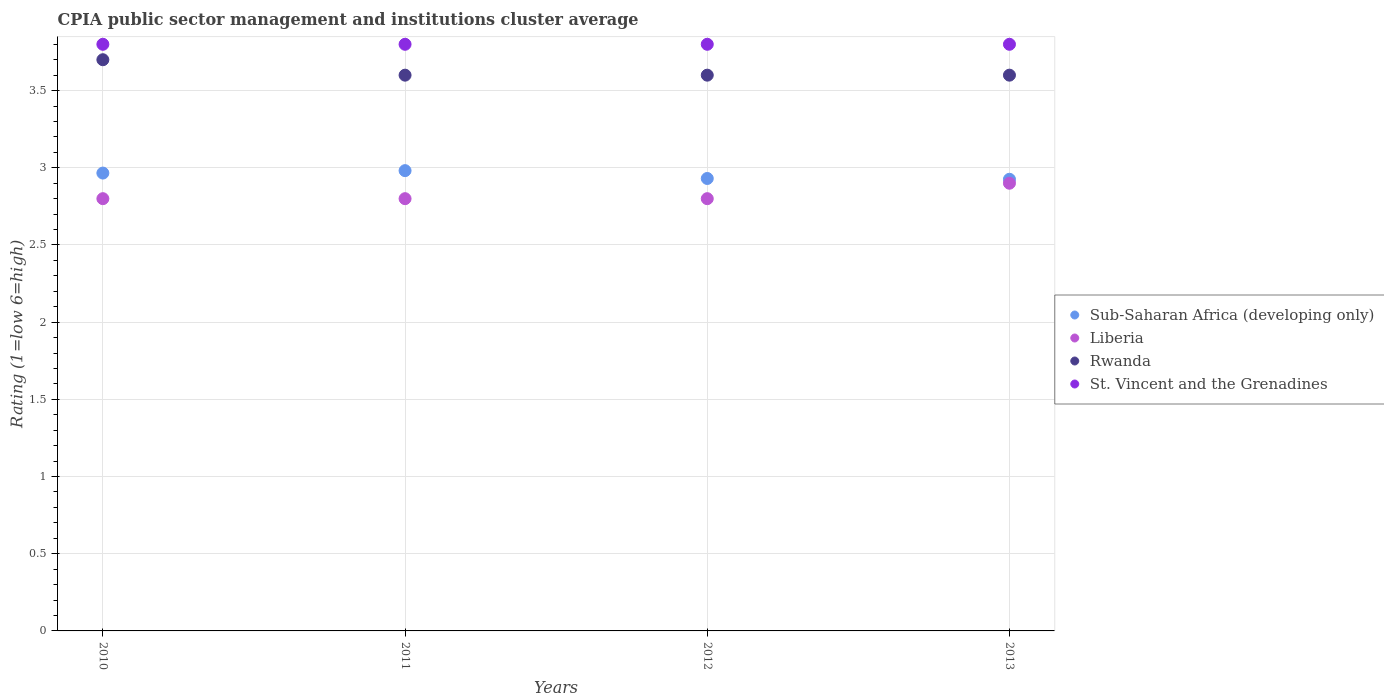What is the CPIA rating in St. Vincent and the Grenadines in 2013?
Keep it short and to the point. 3.8. What is the total CPIA rating in St. Vincent and the Grenadines in the graph?
Your answer should be compact. 15.2. What is the difference between the CPIA rating in Sub-Saharan Africa (developing only) in 2012 and that in 2013?
Offer a very short reply. 0.01. What is the difference between the CPIA rating in Liberia in 2013 and the CPIA rating in Rwanda in 2010?
Offer a terse response. -0.8. What is the average CPIA rating in St. Vincent and the Grenadines per year?
Make the answer very short. 3.8. In the year 2012, what is the difference between the CPIA rating in Sub-Saharan Africa (developing only) and CPIA rating in Liberia?
Your answer should be very brief. 0.13. In how many years, is the CPIA rating in Sub-Saharan Africa (developing only) greater than 1?
Your answer should be very brief. 4. What is the ratio of the CPIA rating in Sub-Saharan Africa (developing only) in 2010 to that in 2013?
Keep it short and to the point. 1.01. What is the difference between the highest and the second highest CPIA rating in Rwanda?
Offer a terse response. 0.1. What is the difference between the highest and the lowest CPIA rating in Rwanda?
Make the answer very short. 0.1. In how many years, is the CPIA rating in Rwanda greater than the average CPIA rating in Rwanda taken over all years?
Provide a short and direct response. 1. Is the sum of the CPIA rating in St. Vincent and the Grenadines in 2011 and 2012 greater than the maximum CPIA rating in Sub-Saharan Africa (developing only) across all years?
Your answer should be compact. Yes. How many dotlines are there?
Keep it short and to the point. 4. Are the values on the major ticks of Y-axis written in scientific E-notation?
Give a very brief answer. No. Does the graph contain any zero values?
Keep it short and to the point. No. What is the title of the graph?
Ensure brevity in your answer.  CPIA public sector management and institutions cluster average. What is the label or title of the X-axis?
Offer a terse response. Years. What is the label or title of the Y-axis?
Provide a short and direct response. Rating (1=low 6=high). What is the Rating (1=low 6=high) in Sub-Saharan Africa (developing only) in 2010?
Keep it short and to the point. 2.97. What is the Rating (1=low 6=high) of Sub-Saharan Africa (developing only) in 2011?
Provide a short and direct response. 2.98. What is the Rating (1=low 6=high) in Sub-Saharan Africa (developing only) in 2012?
Make the answer very short. 2.93. What is the Rating (1=low 6=high) in Liberia in 2012?
Offer a very short reply. 2.8. What is the Rating (1=low 6=high) in Rwanda in 2012?
Ensure brevity in your answer.  3.6. What is the Rating (1=low 6=high) of St. Vincent and the Grenadines in 2012?
Your response must be concise. 3.8. What is the Rating (1=low 6=high) in Sub-Saharan Africa (developing only) in 2013?
Offer a very short reply. 2.93. What is the Rating (1=low 6=high) in Liberia in 2013?
Your answer should be very brief. 2.9. Across all years, what is the maximum Rating (1=low 6=high) in Sub-Saharan Africa (developing only)?
Provide a short and direct response. 2.98. Across all years, what is the maximum Rating (1=low 6=high) of Rwanda?
Make the answer very short. 3.7. Across all years, what is the maximum Rating (1=low 6=high) of St. Vincent and the Grenadines?
Make the answer very short. 3.8. Across all years, what is the minimum Rating (1=low 6=high) of Sub-Saharan Africa (developing only)?
Give a very brief answer. 2.93. Across all years, what is the minimum Rating (1=low 6=high) in Rwanda?
Provide a succinct answer. 3.6. What is the total Rating (1=low 6=high) of Sub-Saharan Africa (developing only) in the graph?
Your answer should be very brief. 11.8. What is the total Rating (1=low 6=high) of St. Vincent and the Grenadines in the graph?
Your answer should be very brief. 15.2. What is the difference between the Rating (1=low 6=high) in Sub-Saharan Africa (developing only) in 2010 and that in 2011?
Your answer should be very brief. -0.02. What is the difference between the Rating (1=low 6=high) of Liberia in 2010 and that in 2011?
Your answer should be very brief. 0. What is the difference between the Rating (1=low 6=high) of Rwanda in 2010 and that in 2011?
Give a very brief answer. 0.1. What is the difference between the Rating (1=low 6=high) in St. Vincent and the Grenadines in 2010 and that in 2011?
Give a very brief answer. 0. What is the difference between the Rating (1=low 6=high) in Sub-Saharan Africa (developing only) in 2010 and that in 2012?
Offer a very short reply. 0.04. What is the difference between the Rating (1=low 6=high) in Liberia in 2010 and that in 2012?
Your answer should be compact. 0. What is the difference between the Rating (1=low 6=high) of St. Vincent and the Grenadines in 2010 and that in 2012?
Ensure brevity in your answer.  0. What is the difference between the Rating (1=low 6=high) in Sub-Saharan Africa (developing only) in 2010 and that in 2013?
Keep it short and to the point. 0.04. What is the difference between the Rating (1=low 6=high) in Liberia in 2010 and that in 2013?
Offer a terse response. -0.1. What is the difference between the Rating (1=low 6=high) of Rwanda in 2010 and that in 2013?
Your response must be concise. 0.1. What is the difference between the Rating (1=low 6=high) of Sub-Saharan Africa (developing only) in 2011 and that in 2012?
Provide a succinct answer. 0.05. What is the difference between the Rating (1=low 6=high) in Liberia in 2011 and that in 2012?
Give a very brief answer. 0. What is the difference between the Rating (1=low 6=high) in St. Vincent and the Grenadines in 2011 and that in 2012?
Provide a short and direct response. 0. What is the difference between the Rating (1=low 6=high) in Sub-Saharan Africa (developing only) in 2011 and that in 2013?
Your response must be concise. 0.06. What is the difference between the Rating (1=low 6=high) of Rwanda in 2011 and that in 2013?
Make the answer very short. 0. What is the difference between the Rating (1=low 6=high) in Sub-Saharan Africa (developing only) in 2012 and that in 2013?
Give a very brief answer. 0.01. What is the difference between the Rating (1=low 6=high) of Rwanda in 2012 and that in 2013?
Offer a very short reply. 0. What is the difference between the Rating (1=low 6=high) of St. Vincent and the Grenadines in 2012 and that in 2013?
Give a very brief answer. 0. What is the difference between the Rating (1=low 6=high) of Sub-Saharan Africa (developing only) in 2010 and the Rating (1=low 6=high) of Liberia in 2011?
Provide a short and direct response. 0.17. What is the difference between the Rating (1=low 6=high) of Sub-Saharan Africa (developing only) in 2010 and the Rating (1=low 6=high) of Rwanda in 2011?
Ensure brevity in your answer.  -0.63. What is the difference between the Rating (1=low 6=high) of Sub-Saharan Africa (developing only) in 2010 and the Rating (1=low 6=high) of St. Vincent and the Grenadines in 2011?
Make the answer very short. -0.83. What is the difference between the Rating (1=low 6=high) in Liberia in 2010 and the Rating (1=low 6=high) in Rwanda in 2011?
Keep it short and to the point. -0.8. What is the difference between the Rating (1=low 6=high) of Sub-Saharan Africa (developing only) in 2010 and the Rating (1=low 6=high) of Liberia in 2012?
Ensure brevity in your answer.  0.17. What is the difference between the Rating (1=low 6=high) of Sub-Saharan Africa (developing only) in 2010 and the Rating (1=low 6=high) of Rwanda in 2012?
Your response must be concise. -0.63. What is the difference between the Rating (1=low 6=high) of Sub-Saharan Africa (developing only) in 2010 and the Rating (1=low 6=high) of St. Vincent and the Grenadines in 2012?
Keep it short and to the point. -0.83. What is the difference between the Rating (1=low 6=high) in Sub-Saharan Africa (developing only) in 2010 and the Rating (1=low 6=high) in Liberia in 2013?
Provide a succinct answer. 0.07. What is the difference between the Rating (1=low 6=high) in Sub-Saharan Africa (developing only) in 2010 and the Rating (1=low 6=high) in Rwanda in 2013?
Your response must be concise. -0.63. What is the difference between the Rating (1=low 6=high) of Sub-Saharan Africa (developing only) in 2010 and the Rating (1=low 6=high) of St. Vincent and the Grenadines in 2013?
Provide a succinct answer. -0.83. What is the difference between the Rating (1=low 6=high) of Sub-Saharan Africa (developing only) in 2011 and the Rating (1=low 6=high) of Liberia in 2012?
Offer a terse response. 0.18. What is the difference between the Rating (1=low 6=high) in Sub-Saharan Africa (developing only) in 2011 and the Rating (1=low 6=high) in Rwanda in 2012?
Ensure brevity in your answer.  -0.62. What is the difference between the Rating (1=low 6=high) of Sub-Saharan Africa (developing only) in 2011 and the Rating (1=low 6=high) of St. Vincent and the Grenadines in 2012?
Offer a terse response. -0.82. What is the difference between the Rating (1=low 6=high) of Liberia in 2011 and the Rating (1=low 6=high) of Rwanda in 2012?
Keep it short and to the point. -0.8. What is the difference between the Rating (1=low 6=high) of Sub-Saharan Africa (developing only) in 2011 and the Rating (1=low 6=high) of Liberia in 2013?
Make the answer very short. 0.08. What is the difference between the Rating (1=low 6=high) of Sub-Saharan Africa (developing only) in 2011 and the Rating (1=low 6=high) of Rwanda in 2013?
Your answer should be very brief. -0.62. What is the difference between the Rating (1=low 6=high) in Sub-Saharan Africa (developing only) in 2011 and the Rating (1=low 6=high) in St. Vincent and the Grenadines in 2013?
Offer a terse response. -0.82. What is the difference between the Rating (1=low 6=high) in Rwanda in 2011 and the Rating (1=low 6=high) in St. Vincent and the Grenadines in 2013?
Provide a succinct answer. -0.2. What is the difference between the Rating (1=low 6=high) in Sub-Saharan Africa (developing only) in 2012 and the Rating (1=low 6=high) in Liberia in 2013?
Your response must be concise. 0.03. What is the difference between the Rating (1=low 6=high) of Sub-Saharan Africa (developing only) in 2012 and the Rating (1=low 6=high) of Rwanda in 2013?
Offer a very short reply. -0.67. What is the difference between the Rating (1=low 6=high) in Sub-Saharan Africa (developing only) in 2012 and the Rating (1=low 6=high) in St. Vincent and the Grenadines in 2013?
Offer a terse response. -0.87. What is the difference between the Rating (1=low 6=high) in Liberia in 2012 and the Rating (1=low 6=high) in Rwanda in 2013?
Ensure brevity in your answer.  -0.8. What is the difference between the Rating (1=low 6=high) in Liberia in 2012 and the Rating (1=low 6=high) in St. Vincent and the Grenadines in 2013?
Give a very brief answer. -1. What is the average Rating (1=low 6=high) of Sub-Saharan Africa (developing only) per year?
Your answer should be compact. 2.95. What is the average Rating (1=low 6=high) in Liberia per year?
Your answer should be very brief. 2.83. What is the average Rating (1=low 6=high) in Rwanda per year?
Offer a terse response. 3.62. What is the average Rating (1=low 6=high) in St. Vincent and the Grenadines per year?
Provide a succinct answer. 3.8. In the year 2010, what is the difference between the Rating (1=low 6=high) of Sub-Saharan Africa (developing only) and Rating (1=low 6=high) of Liberia?
Provide a succinct answer. 0.17. In the year 2010, what is the difference between the Rating (1=low 6=high) in Sub-Saharan Africa (developing only) and Rating (1=low 6=high) in Rwanda?
Provide a succinct answer. -0.73. In the year 2010, what is the difference between the Rating (1=low 6=high) in Sub-Saharan Africa (developing only) and Rating (1=low 6=high) in St. Vincent and the Grenadines?
Provide a succinct answer. -0.83. In the year 2010, what is the difference between the Rating (1=low 6=high) of Rwanda and Rating (1=low 6=high) of St. Vincent and the Grenadines?
Provide a short and direct response. -0.1. In the year 2011, what is the difference between the Rating (1=low 6=high) of Sub-Saharan Africa (developing only) and Rating (1=low 6=high) of Liberia?
Your response must be concise. 0.18. In the year 2011, what is the difference between the Rating (1=low 6=high) in Sub-Saharan Africa (developing only) and Rating (1=low 6=high) in Rwanda?
Make the answer very short. -0.62. In the year 2011, what is the difference between the Rating (1=low 6=high) of Sub-Saharan Africa (developing only) and Rating (1=low 6=high) of St. Vincent and the Grenadines?
Give a very brief answer. -0.82. In the year 2011, what is the difference between the Rating (1=low 6=high) of Liberia and Rating (1=low 6=high) of Rwanda?
Provide a short and direct response. -0.8. In the year 2012, what is the difference between the Rating (1=low 6=high) in Sub-Saharan Africa (developing only) and Rating (1=low 6=high) in Liberia?
Give a very brief answer. 0.13. In the year 2012, what is the difference between the Rating (1=low 6=high) in Sub-Saharan Africa (developing only) and Rating (1=low 6=high) in Rwanda?
Ensure brevity in your answer.  -0.67. In the year 2012, what is the difference between the Rating (1=low 6=high) of Sub-Saharan Africa (developing only) and Rating (1=low 6=high) of St. Vincent and the Grenadines?
Your response must be concise. -0.87. In the year 2012, what is the difference between the Rating (1=low 6=high) in Liberia and Rating (1=low 6=high) in Rwanda?
Your answer should be very brief. -0.8. In the year 2012, what is the difference between the Rating (1=low 6=high) of Liberia and Rating (1=low 6=high) of St. Vincent and the Grenadines?
Provide a short and direct response. -1. In the year 2013, what is the difference between the Rating (1=low 6=high) in Sub-Saharan Africa (developing only) and Rating (1=low 6=high) in Liberia?
Make the answer very short. 0.03. In the year 2013, what is the difference between the Rating (1=low 6=high) of Sub-Saharan Africa (developing only) and Rating (1=low 6=high) of Rwanda?
Your answer should be compact. -0.67. In the year 2013, what is the difference between the Rating (1=low 6=high) of Sub-Saharan Africa (developing only) and Rating (1=low 6=high) of St. Vincent and the Grenadines?
Keep it short and to the point. -0.87. In the year 2013, what is the difference between the Rating (1=low 6=high) in Liberia and Rating (1=low 6=high) in St. Vincent and the Grenadines?
Your response must be concise. -0.9. In the year 2013, what is the difference between the Rating (1=low 6=high) of Rwanda and Rating (1=low 6=high) of St. Vincent and the Grenadines?
Your answer should be very brief. -0.2. What is the ratio of the Rating (1=low 6=high) in Sub-Saharan Africa (developing only) in 2010 to that in 2011?
Your answer should be very brief. 0.99. What is the ratio of the Rating (1=low 6=high) in Liberia in 2010 to that in 2011?
Provide a short and direct response. 1. What is the ratio of the Rating (1=low 6=high) in Rwanda in 2010 to that in 2011?
Provide a succinct answer. 1.03. What is the ratio of the Rating (1=low 6=high) in St. Vincent and the Grenadines in 2010 to that in 2011?
Keep it short and to the point. 1. What is the ratio of the Rating (1=low 6=high) of Sub-Saharan Africa (developing only) in 2010 to that in 2012?
Make the answer very short. 1.01. What is the ratio of the Rating (1=low 6=high) of Liberia in 2010 to that in 2012?
Your answer should be compact. 1. What is the ratio of the Rating (1=low 6=high) in Rwanda in 2010 to that in 2012?
Your answer should be compact. 1.03. What is the ratio of the Rating (1=low 6=high) in Sub-Saharan Africa (developing only) in 2010 to that in 2013?
Give a very brief answer. 1.01. What is the ratio of the Rating (1=low 6=high) in Liberia in 2010 to that in 2013?
Your response must be concise. 0.97. What is the ratio of the Rating (1=low 6=high) in Rwanda in 2010 to that in 2013?
Your answer should be compact. 1.03. What is the ratio of the Rating (1=low 6=high) in St. Vincent and the Grenadines in 2010 to that in 2013?
Your answer should be compact. 1. What is the ratio of the Rating (1=low 6=high) in Sub-Saharan Africa (developing only) in 2011 to that in 2012?
Offer a terse response. 1.02. What is the ratio of the Rating (1=low 6=high) in Sub-Saharan Africa (developing only) in 2011 to that in 2013?
Keep it short and to the point. 1.02. What is the ratio of the Rating (1=low 6=high) in Liberia in 2011 to that in 2013?
Keep it short and to the point. 0.97. What is the ratio of the Rating (1=low 6=high) of Rwanda in 2011 to that in 2013?
Keep it short and to the point. 1. What is the ratio of the Rating (1=low 6=high) in St. Vincent and the Grenadines in 2011 to that in 2013?
Give a very brief answer. 1. What is the ratio of the Rating (1=low 6=high) in Liberia in 2012 to that in 2013?
Offer a terse response. 0.97. What is the ratio of the Rating (1=low 6=high) of Rwanda in 2012 to that in 2013?
Make the answer very short. 1. What is the difference between the highest and the second highest Rating (1=low 6=high) of Sub-Saharan Africa (developing only)?
Give a very brief answer. 0.02. What is the difference between the highest and the second highest Rating (1=low 6=high) of Liberia?
Keep it short and to the point. 0.1. What is the difference between the highest and the second highest Rating (1=low 6=high) in Rwanda?
Give a very brief answer. 0.1. What is the difference between the highest and the second highest Rating (1=low 6=high) of St. Vincent and the Grenadines?
Offer a terse response. 0. What is the difference between the highest and the lowest Rating (1=low 6=high) in Sub-Saharan Africa (developing only)?
Provide a short and direct response. 0.06. What is the difference between the highest and the lowest Rating (1=low 6=high) of Rwanda?
Provide a succinct answer. 0.1. 